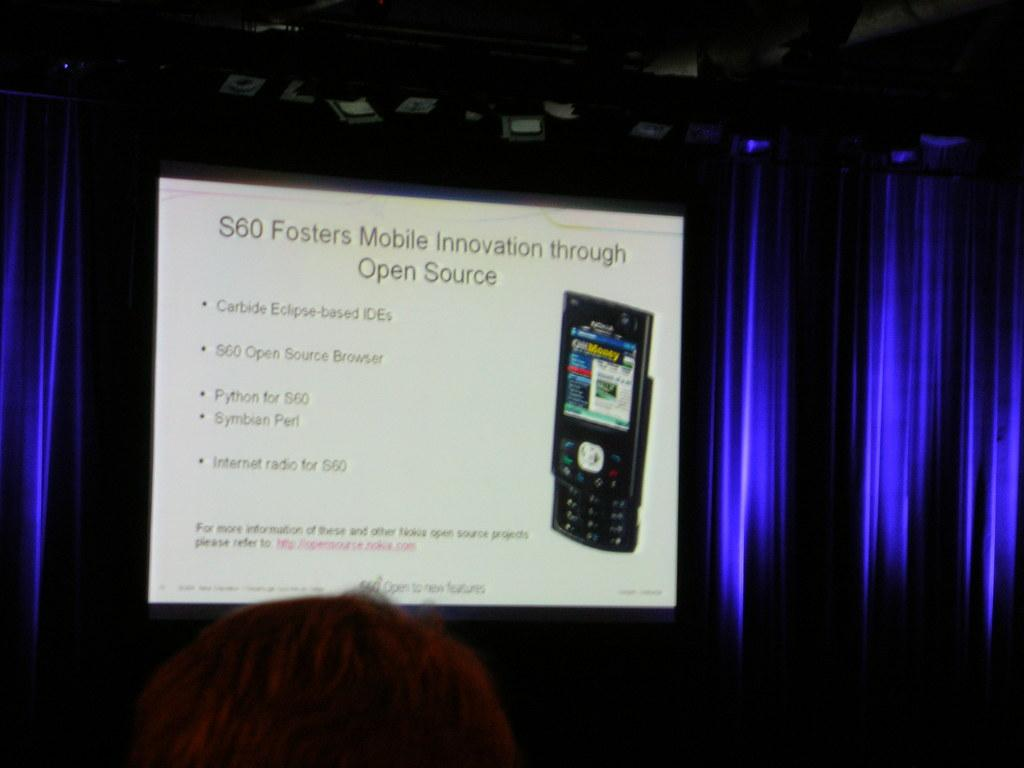What can be seen in the image that is typically used for communication? There is a mobile in the image. What is displayed on the mobile's screen? There is text visible on the mobile's screen. What else is present in the image besides the mobile? There are objects in the image. How would you describe the overall lighting in the image? The background of the image is dark. What type of wood is the pig using to write the idea on the mobile's screen? There is no pig or wood present in the image, and therefore no such activity can be observed. 